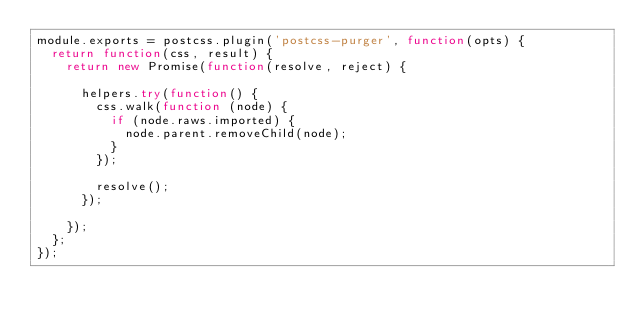Convert code to text. <code><loc_0><loc_0><loc_500><loc_500><_JavaScript_>module.exports = postcss.plugin('postcss-purger', function(opts) {
	return function(css, result) {
		return new Promise(function(resolve, reject) {

			helpers.try(function() {
				css.walk(function (node) {
					if (node.raws.imported) {
						node.parent.removeChild(node);
					}
				});

				resolve();
			});

		});
	};
});
</code> 